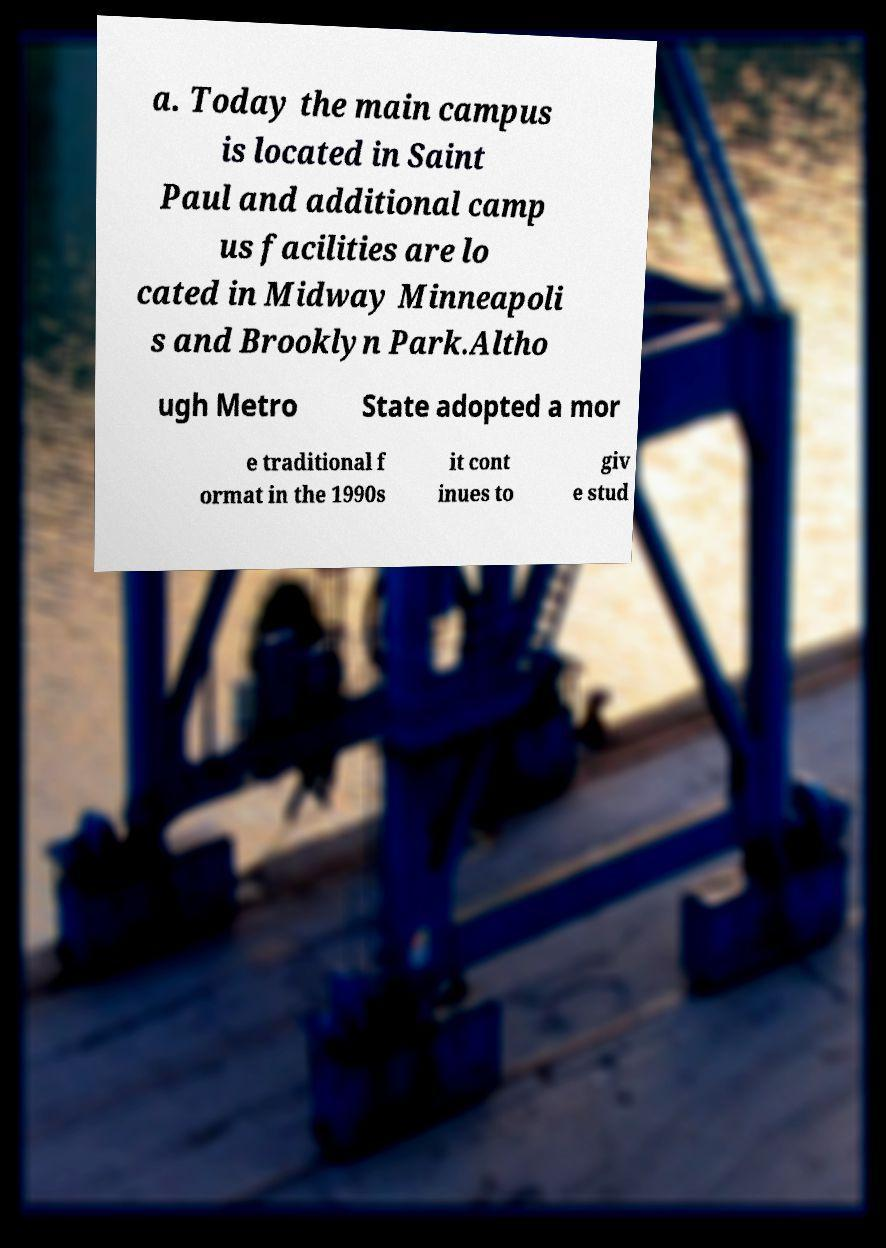There's text embedded in this image that I need extracted. Can you transcribe it verbatim? a. Today the main campus is located in Saint Paul and additional camp us facilities are lo cated in Midway Minneapoli s and Brooklyn Park.Altho ugh Metro State adopted a mor e traditional f ormat in the 1990s it cont inues to giv e stud 